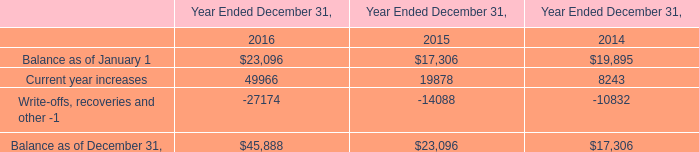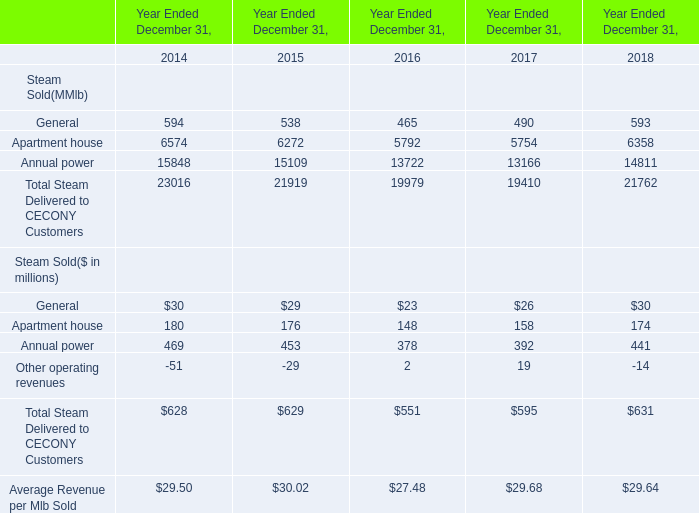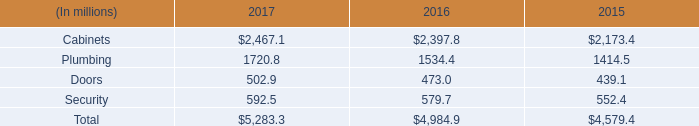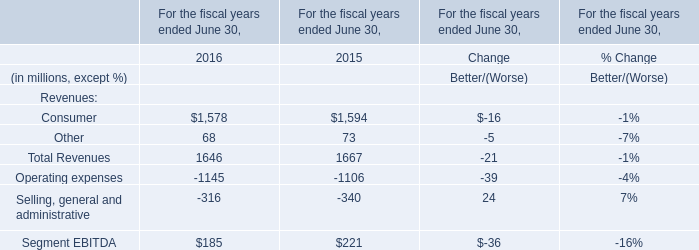What is the ratio of Average Revenue per Mlb Sold in Table 1 to the Other in Table 3 in 2015? 
Computations: (30.02 / 73)
Answer: 0.41123. 